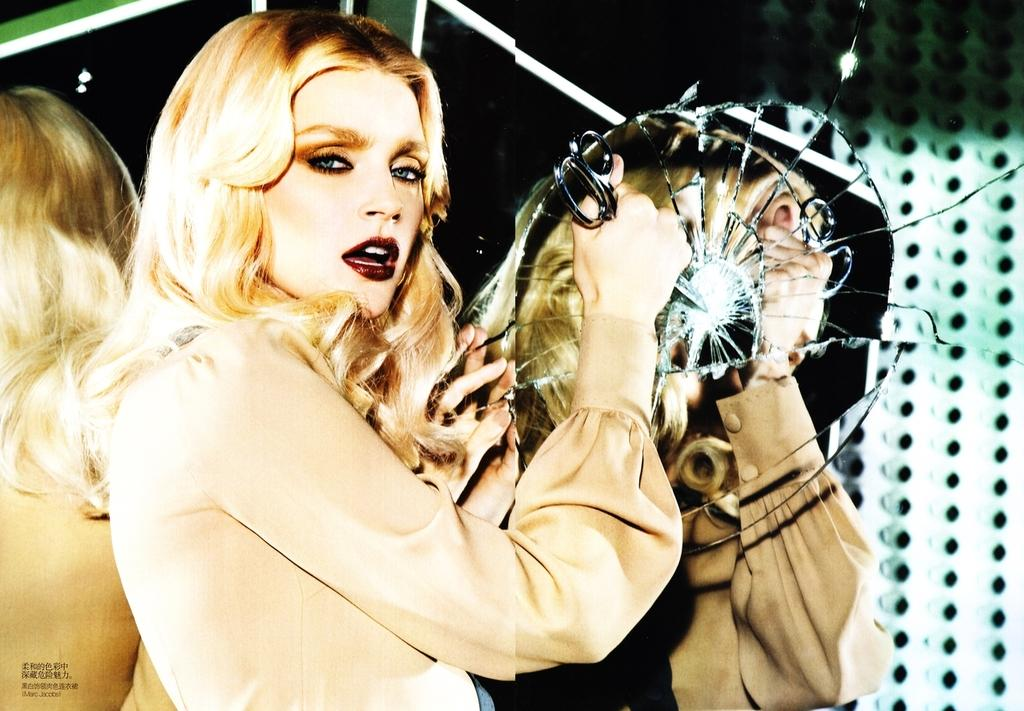Who is present in the image? There is a woman in the image. What is the woman holding in her hand? The woman is holding a pair of scissors. What object is broken and located on the right side of the image? There is a broken mirror on the right side of the image. What type of book is the woman reading in the image? There is no book present in the image, and the woman is not reading. 